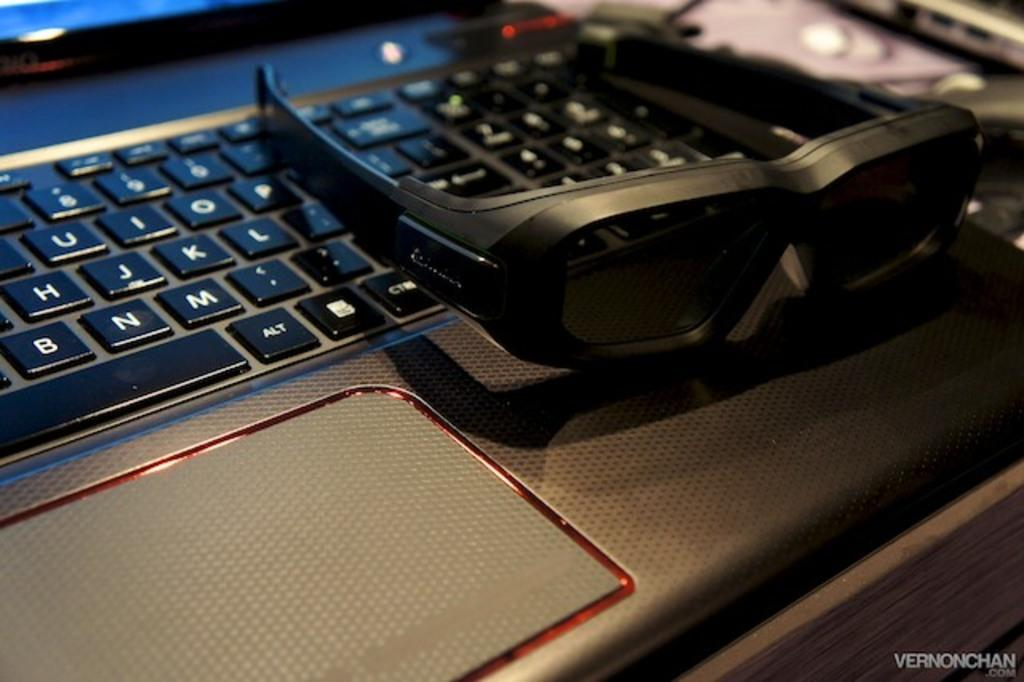Provide a one-sentence caption for the provided image. A pair of black glasses sitting on a laptop where an alt and ctrl key can be seen. 